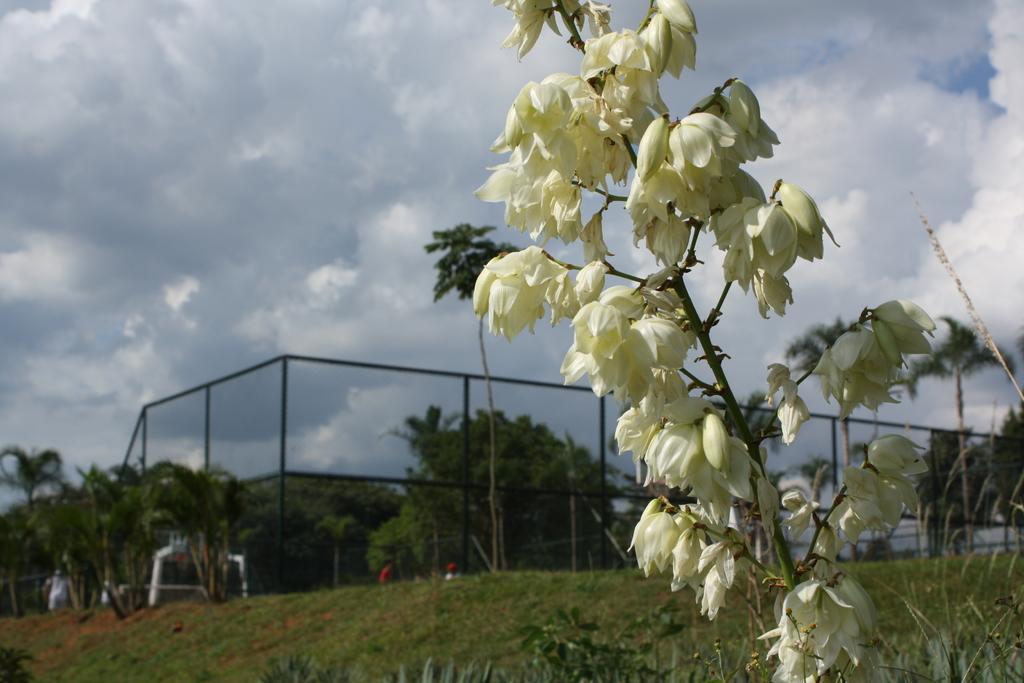How would you summarize this image in a sentence or two? In this image I can see plants, grass, fence, trees and group of people. In the background I can see the sky. This image is taken may be in the park. 